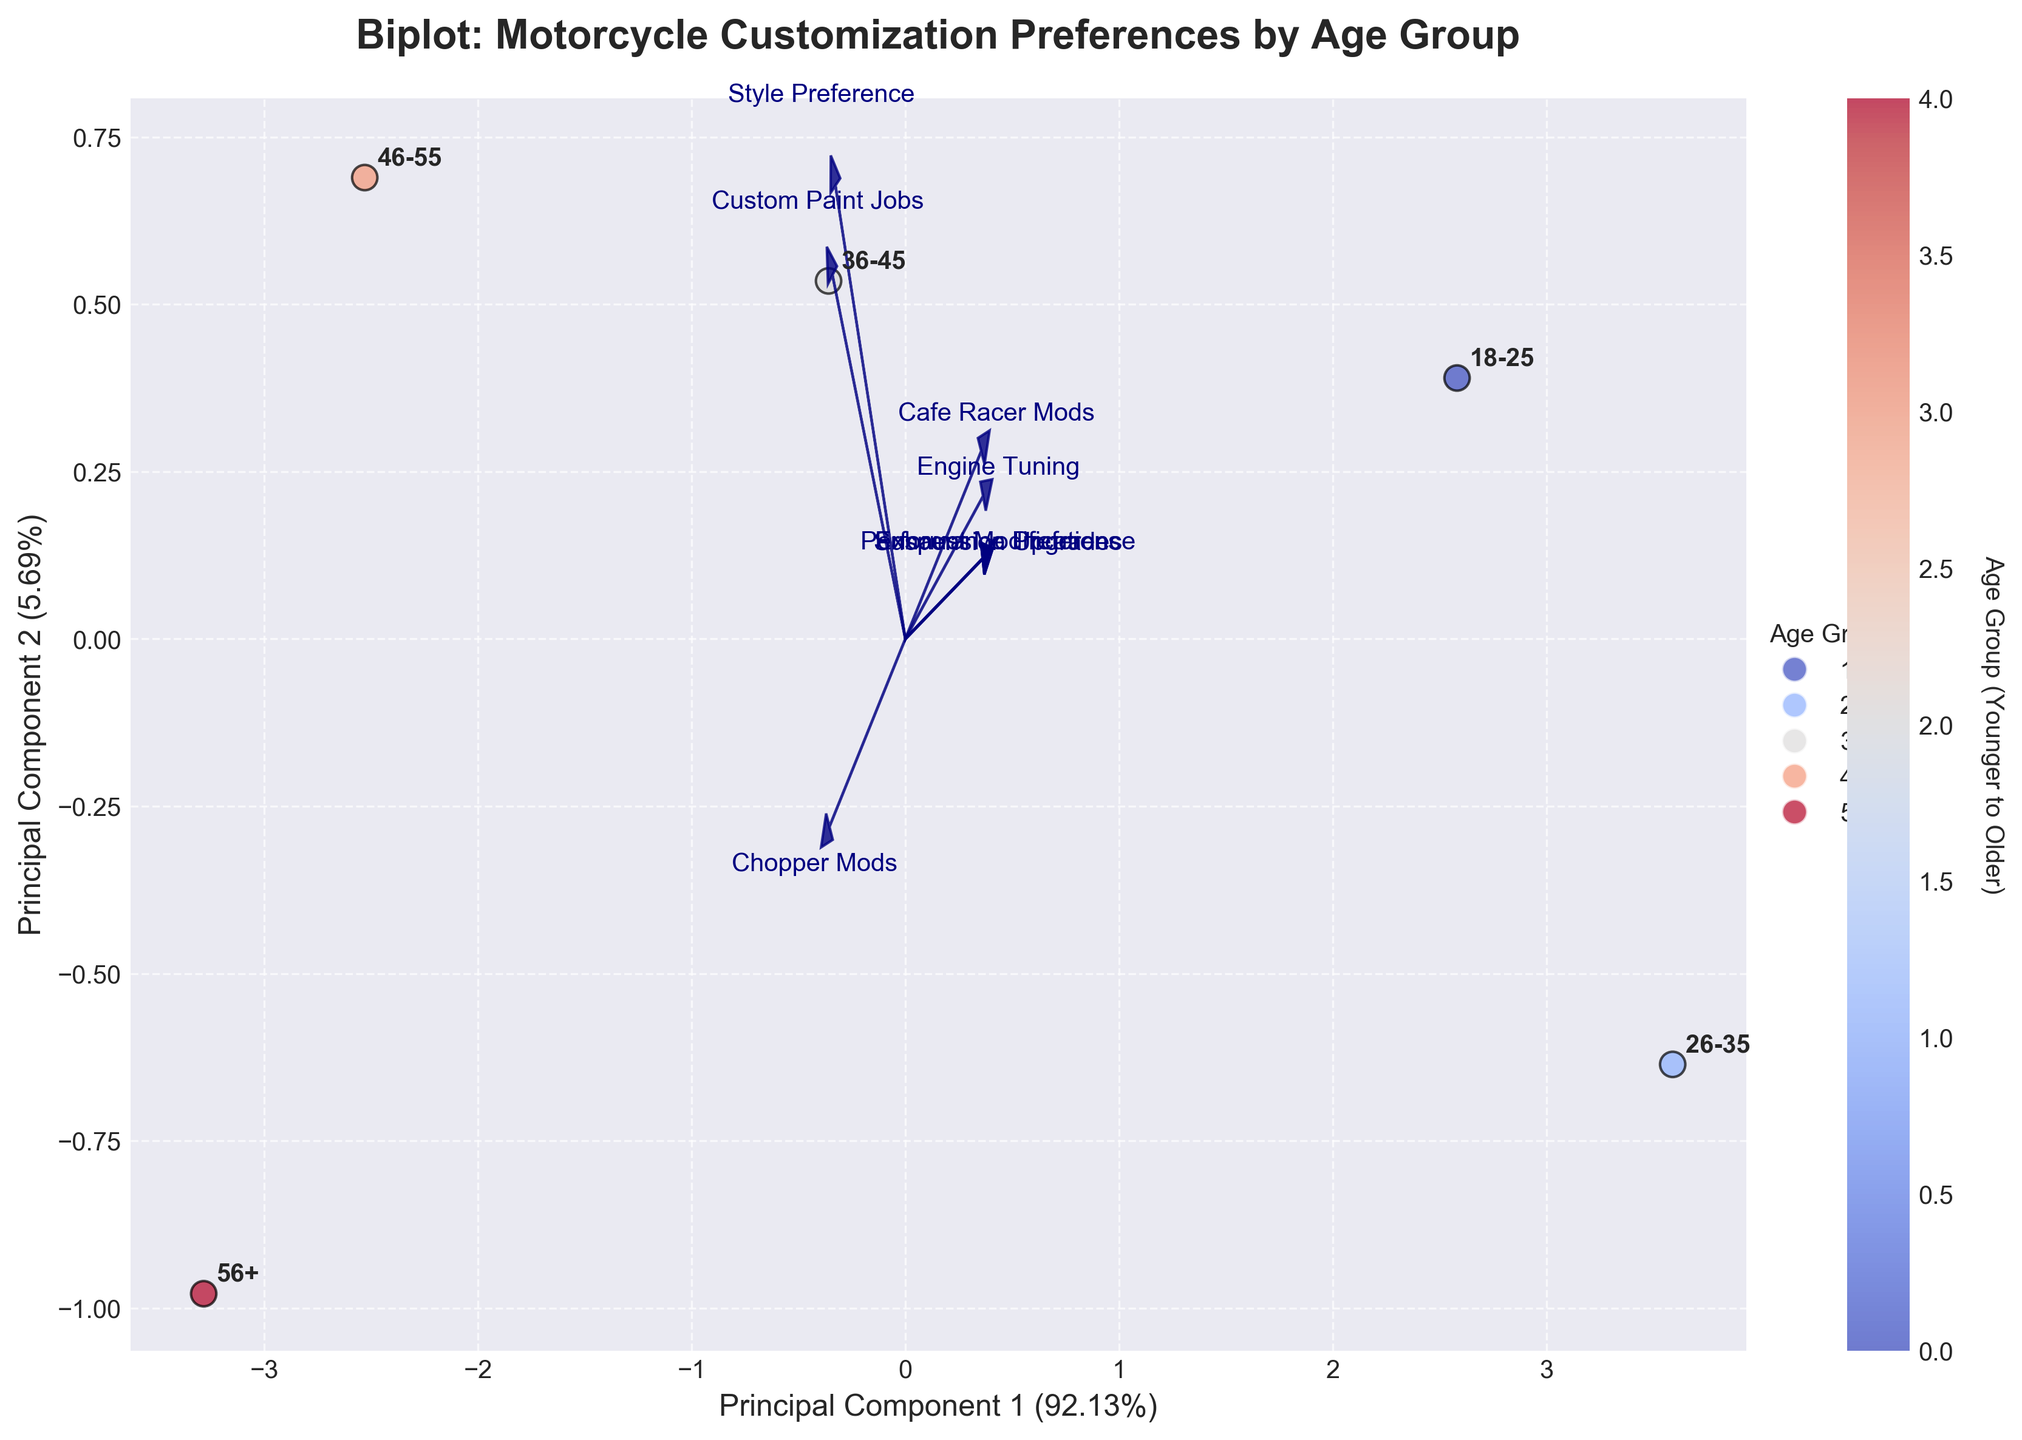What is the title of the figure? The title is typically found at the top of the figure in bold text.
Answer: Biplot: Motorcycle Customization Preferences by Age Group How many age groups are represented in the plot? By looking at the annotated points in the scatter plot, we can count the distinct age groups.
Answer: Five Which age group prefers custom paint jobs the most? We locate the vectors related to custom paint jobs and identify which age group is closest to this vector.
Answer: 46-55 Which age group has the highest preference for performance modifications overall? By observing how close the age group positions are to the performance-related vectors (Engine Tuning and Suspension Upgrades), we can determine the highest preference.
Answer: 26-35 Is there any age group that has a strong preference for both Chopper Mods and Style Preference? Look at the positions relative to the vectors for Chopper Mods and Style Preference. Consider if any group is close to both vectors.
Answer: 46-55 Which feature vector is most aligned with Principal Component 1 (PC1)? We determine which feature vector points most parallelly along the PC1 axis, represented on the plot's x-axis.
Answer: Engine Tuning What is the angle between the vectors for Custom Paint Jobs and Exhaust Modifications? By visually inspecting the plot, approximate the angle formed between the two feature vectors.
Answer: Acute angle What age group has the least preference for Cafe Racer Mods and why? Look at which age group is positioned farthest from the vector representing Cafe Racer Mods.
Answer: 56+ because it is positioned far from the Cafe Racer Mods vector Compare the distance between the 18-25 and 36-45 age groups concerning Performance Preference. Who is closer? Measure which age group is placed nearer to the Performance Preference vector by following the direction of the vector.
Answer: 18-25 Which components explain most of the variation in the data, PC1 or PC2? The axes are labeled with the variance they explain; compare the percentages for PC1 and PC2.
Answer: PC1 